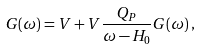<formula> <loc_0><loc_0><loc_500><loc_500>G ( \omega ) = V + V \frac { Q _ { P } } { \omega - H _ { 0 } } G ( \omega ) \, ,</formula> 